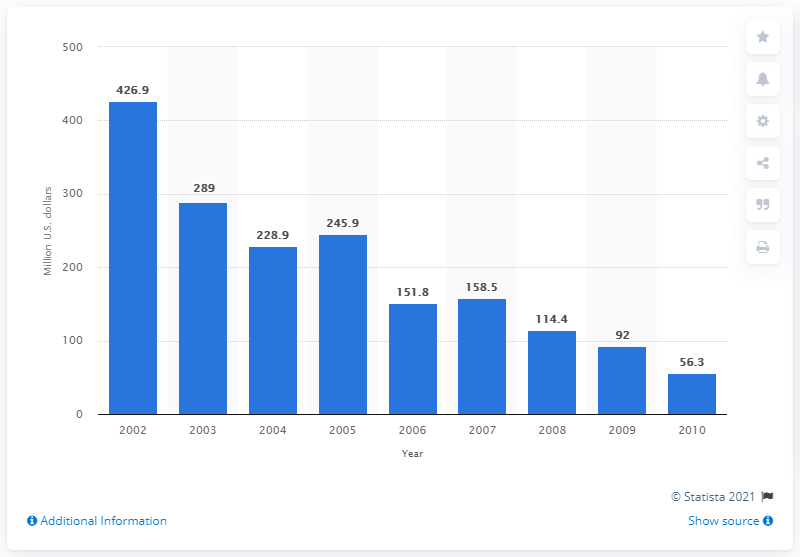List a handful of essential elements in this visual. In 2009, the value of U.S. product shipments of leather belts was 92 million dollars. 